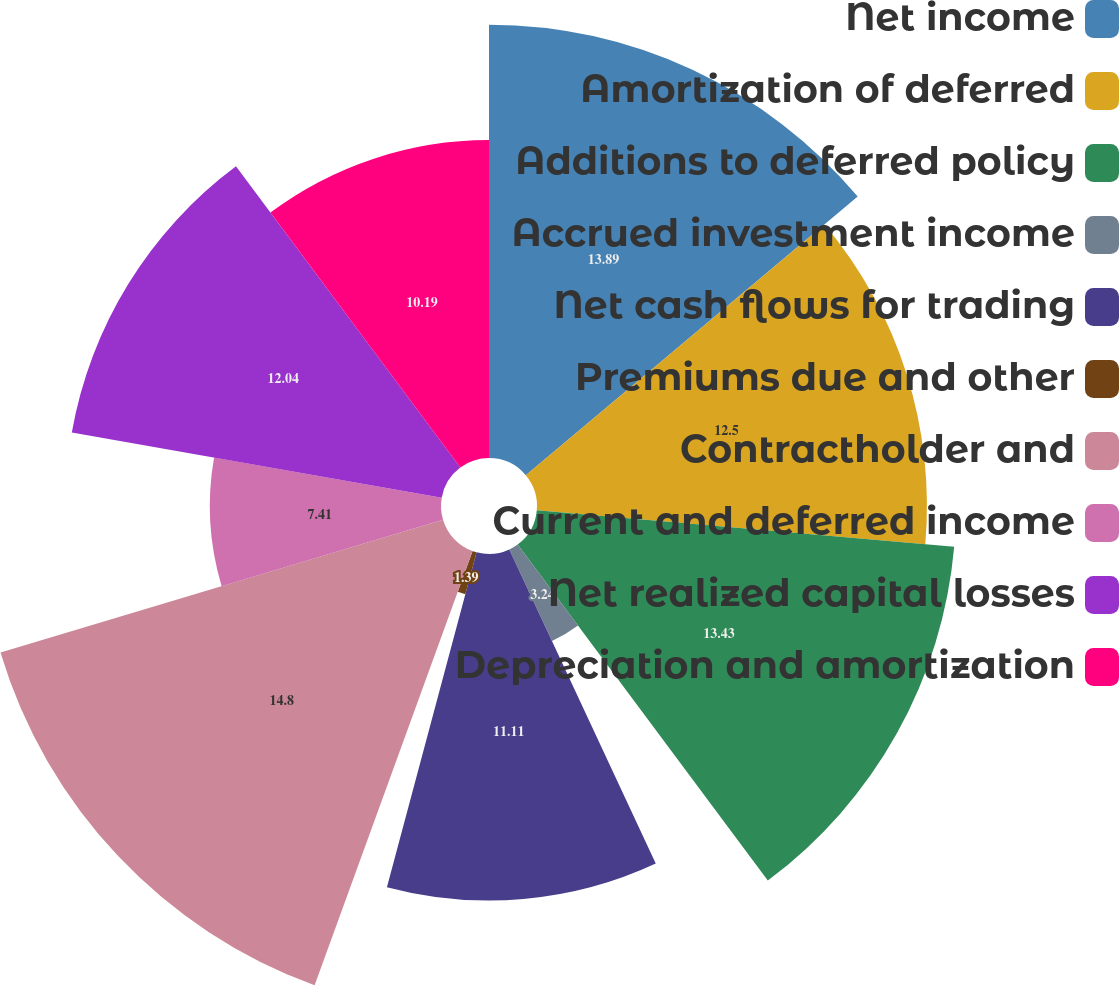Convert chart to OTSL. <chart><loc_0><loc_0><loc_500><loc_500><pie_chart><fcel>Net income<fcel>Amortization of deferred<fcel>Additions to deferred policy<fcel>Accrued investment income<fcel>Net cash flows for trading<fcel>Premiums due and other<fcel>Contractholder and<fcel>Current and deferred income<fcel>Net realized capital losses<fcel>Depreciation and amortization<nl><fcel>13.89%<fcel>12.5%<fcel>13.43%<fcel>3.24%<fcel>11.11%<fcel>1.39%<fcel>14.81%<fcel>7.41%<fcel>12.04%<fcel>10.19%<nl></chart> 